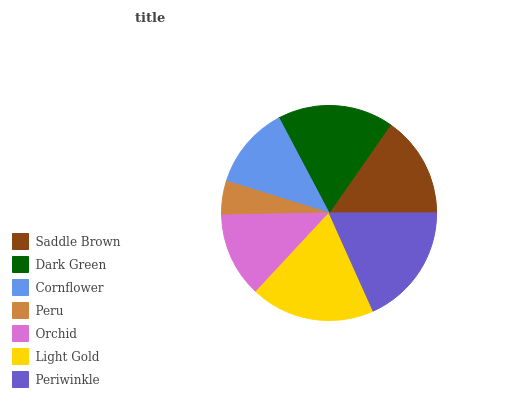Is Peru the minimum?
Answer yes or no. Yes. Is Light Gold the maximum?
Answer yes or no. Yes. Is Dark Green the minimum?
Answer yes or no. No. Is Dark Green the maximum?
Answer yes or no. No. Is Dark Green greater than Saddle Brown?
Answer yes or no. Yes. Is Saddle Brown less than Dark Green?
Answer yes or no. Yes. Is Saddle Brown greater than Dark Green?
Answer yes or no. No. Is Dark Green less than Saddle Brown?
Answer yes or no. No. Is Saddle Brown the high median?
Answer yes or no. Yes. Is Saddle Brown the low median?
Answer yes or no. Yes. Is Dark Green the high median?
Answer yes or no. No. Is Cornflower the low median?
Answer yes or no. No. 